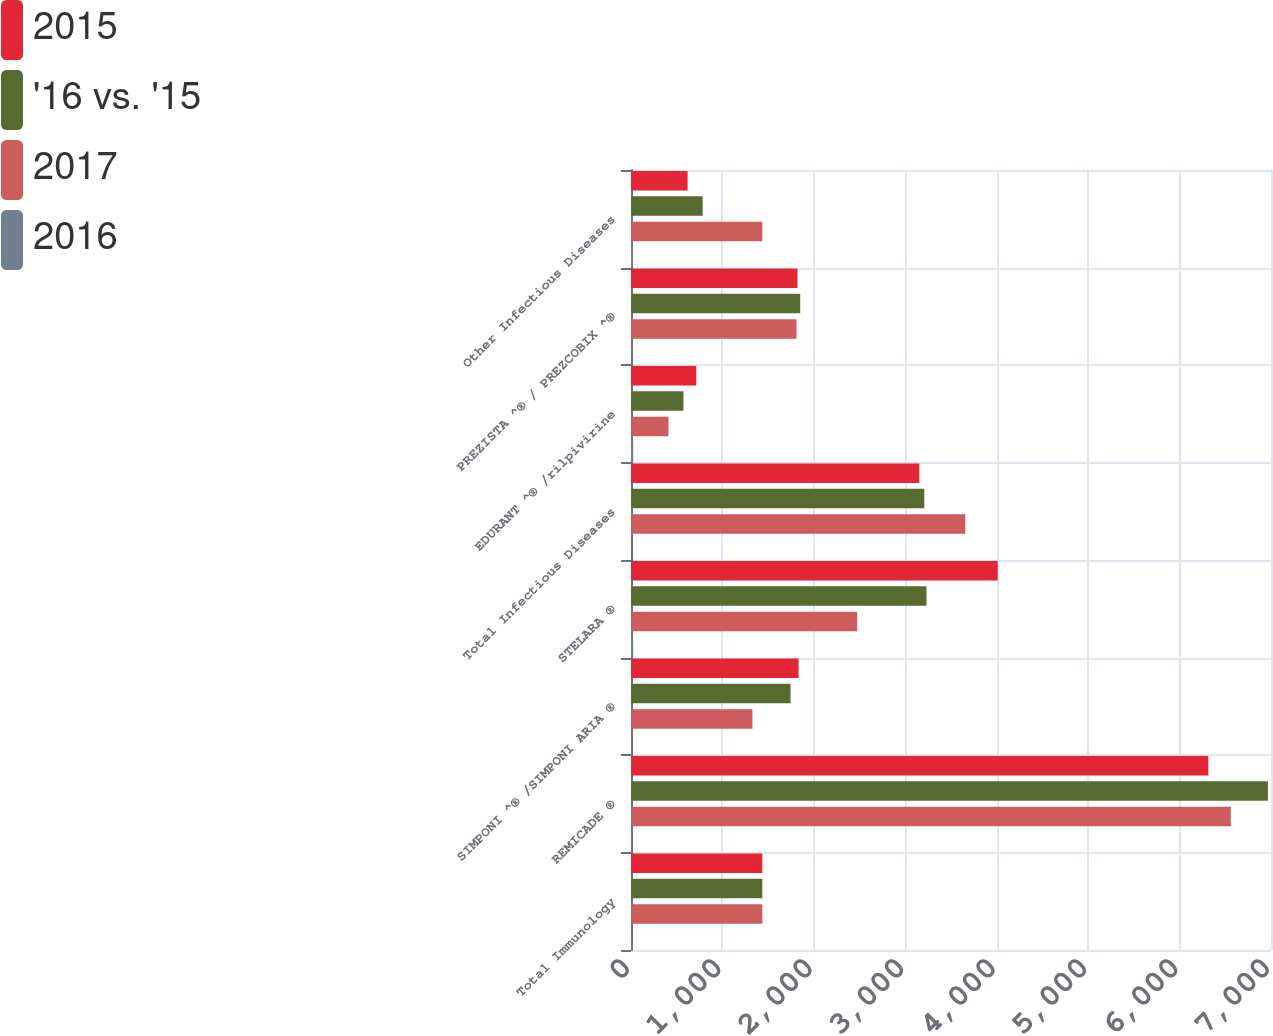Convert chart. <chart><loc_0><loc_0><loc_500><loc_500><stacked_bar_chart><ecel><fcel>Total Immunology<fcel>REMICADE ®<fcel>SIMPONI ^® /SIMPONI ARIA ®<fcel>STELARA ®<fcel>Total Infectious Diseases<fcel>EDURANT ^® /rilpivirine<fcel>PREZISTA ^® / PREZCOBIX ^®<fcel>Other Infectious Diseases<nl><fcel>2015<fcel>1436<fcel>6315<fcel>1833<fcel>4011<fcel>3154<fcel>714<fcel>1821<fcel>619<nl><fcel>'16 vs. '15<fcel>1436<fcel>6966<fcel>1745<fcel>3232<fcel>3208<fcel>573<fcel>1851<fcel>784<nl><fcel>2017<fcel>1436<fcel>6561<fcel>1328<fcel>2474<fcel>3656<fcel>410<fcel>1810<fcel>1436<nl><fcel>2016<fcel>2.3<fcel>9.3<fcel>5<fcel>24.1<fcel>1.7<fcel>24.6<fcel>1.6<fcel>21<nl></chart> 